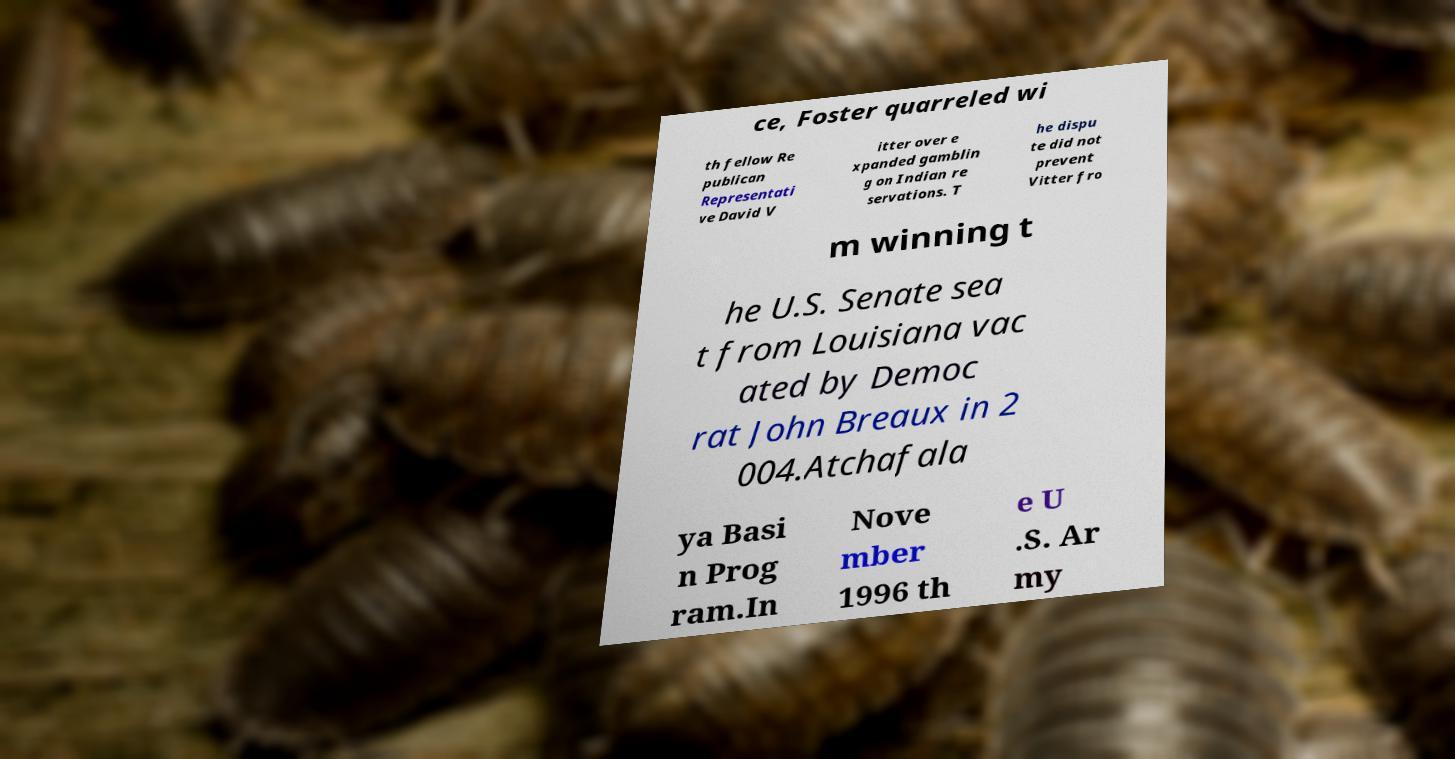Could you assist in decoding the text presented in this image and type it out clearly? ce, Foster quarreled wi th fellow Re publican Representati ve David V itter over e xpanded gamblin g on Indian re servations. T he dispu te did not prevent Vitter fro m winning t he U.S. Senate sea t from Louisiana vac ated by Democ rat John Breaux in 2 004.Atchafala ya Basi n Prog ram.In Nove mber 1996 th e U .S. Ar my 